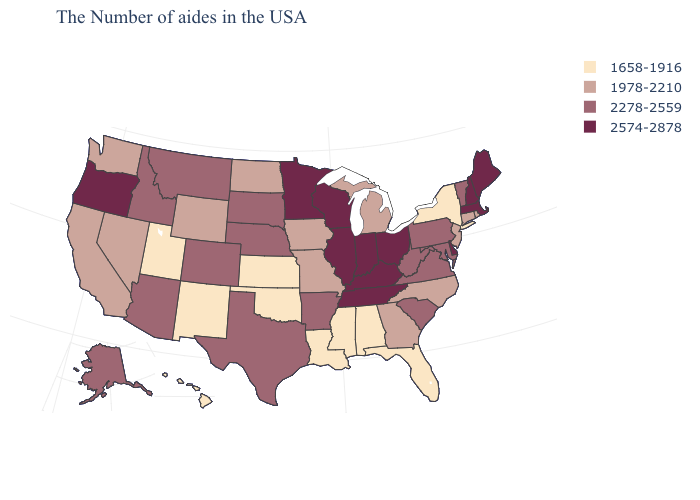How many symbols are there in the legend?
Concise answer only. 4. What is the value of Maryland?
Answer briefly. 2278-2559. What is the value of Georgia?
Concise answer only. 1978-2210. What is the value of South Dakota?
Give a very brief answer. 2278-2559. Name the states that have a value in the range 1658-1916?
Short answer required. New York, Florida, Alabama, Mississippi, Louisiana, Kansas, Oklahoma, New Mexico, Utah, Hawaii. Name the states that have a value in the range 1978-2210?
Keep it brief. Rhode Island, Connecticut, New Jersey, North Carolina, Georgia, Michigan, Missouri, Iowa, North Dakota, Wyoming, Nevada, California, Washington. Among the states that border Virginia , does Maryland have the highest value?
Concise answer only. No. What is the lowest value in the USA?
Keep it brief. 1658-1916. What is the highest value in states that border Pennsylvania?
Give a very brief answer. 2574-2878. Does North Dakota have the lowest value in the MidWest?
Answer briefly. No. What is the highest value in the USA?
Answer briefly. 2574-2878. Name the states that have a value in the range 2278-2559?
Concise answer only. Vermont, Maryland, Pennsylvania, Virginia, South Carolina, West Virginia, Arkansas, Nebraska, Texas, South Dakota, Colorado, Montana, Arizona, Idaho, Alaska. Does Kentucky have the highest value in the South?
Write a very short answer. Yes. Name the states that have a value in the range 2278-2559?
Concise answer only. Vermont, Maryland, Pennsylvania, Virginia, South Carolina, West Virginia, Arkansas, Nebraska, Texas, South Dakota, Colorado, Montana, Arizona, Idaho, Alaska. What is the lowest value in the USA?
Short answer required. 1658-1916. 